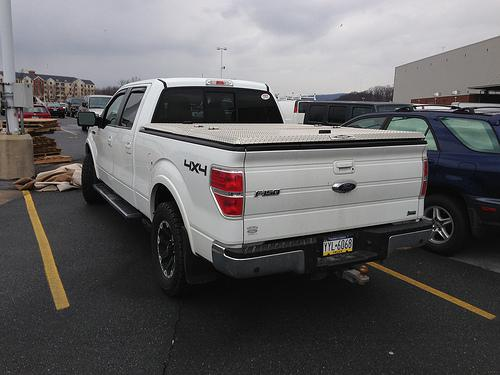Question: what color are the lines on the ground?
Choices:
A. White.
B. Orange.
C. Yellow.
D. Blue.
Answer with the letter. Answer: C Question: what is the color of the vehicle nearest the camera?
Choices:
A. White.
B. Black.
C. Red.
D. Blue.
Answer with the letter. Answer: A Question: what type of vehicle is the nearest vehicle?
Choices:
A. Car.
B. Limousine.
C. Truck.
D. Suv.
Answer with the letter. Answer: C 